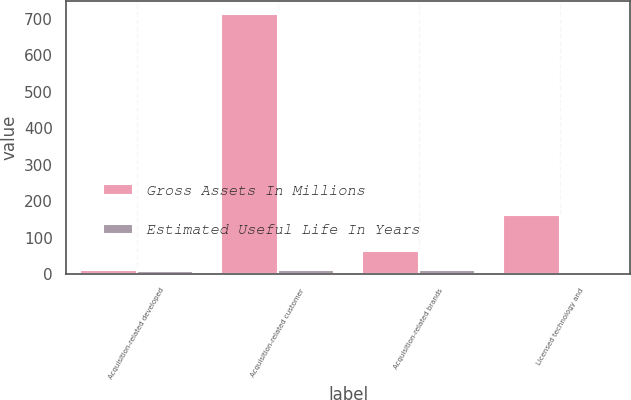Convert chart. <chart><loc_0><loc_0><loc_500><loc_500><stacked_bar_chart><ecel><fcel>Acquisition-related developed<fcel>Acquisition-related customer<fcel>Acquisition-related brands<fcel>Licensed technology and<nl><fcel>Gross Assets In Millions<fcel>12<fcel>713<fcel>64<fcel>162<nl><fcel>Estimated Useful Life In Years<fcel>9<fcel>12<fcel>10<fcel>7<nl></chart> 